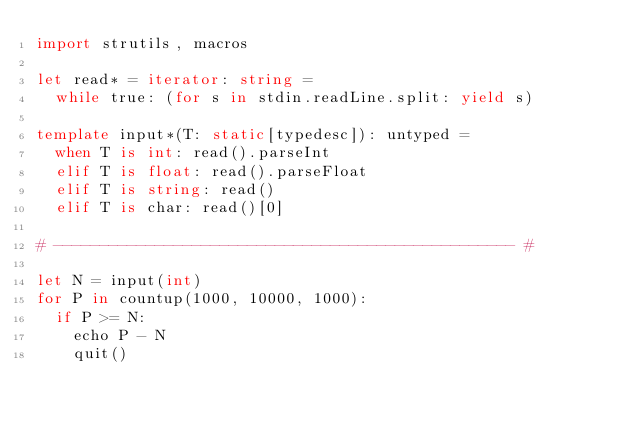<code> <loc_0><loc_0><loc_500><loc_500><_Nim_>import strutils, macros
 
let read* = iterator: string =
  while true: (for s in stdin.readLine.split: yield s)
 
template input*(T: static[typedesc]): untyped = 
  when T is int: read().parseInt
  elif T is float: read().parseFloat
  elif T is string: read()
  elif T is char: read()[0]
 
# -------------------------------------------------- #

let N = input(int)
for P in countup(1000, 10000, 1000):
  if P >= N:
    echo P - N
    quit()</code> 